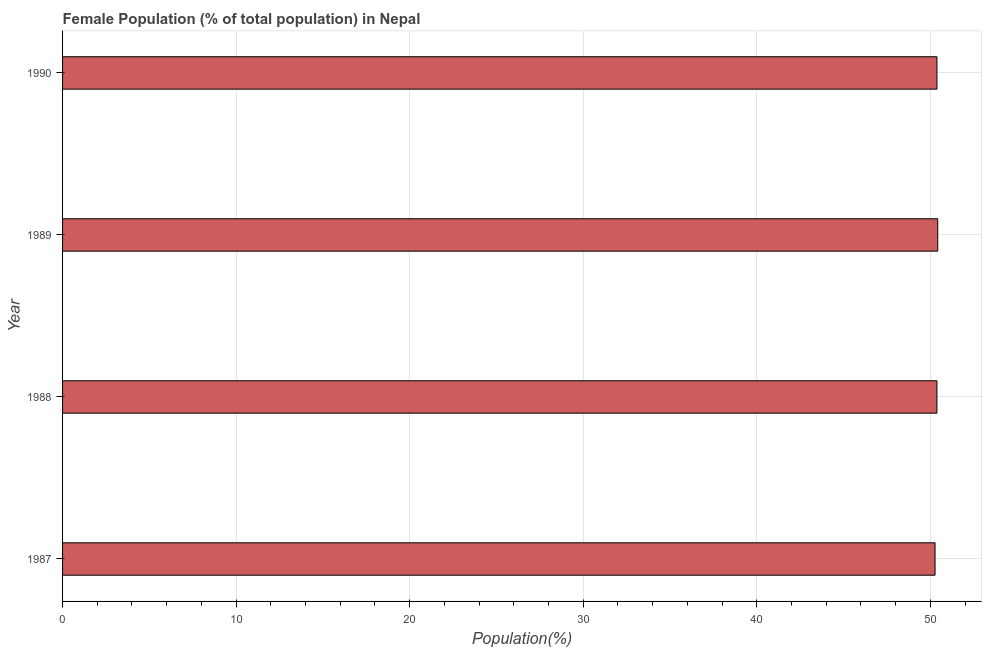Does the graph contain any zero values?
Provide a succinct answer. No. What is the title of the graph?
Provide a short and direct response. Female Population (% of total population) in Nepal. What is the label or title of the X-axis?
Provide a succinct answer. Population(%). What is the label or title of the Y-axis?
Offer a terse response. Year. What is the female population in 1987?
Provide a succinct answer. 50.27. Across all years, what is the maximum female population?
Give a very brief answer. 50.43. Across all years, what is the minimum female population?
Your answer should be very brief. 50.27. What is the sum of the female population?
Keep it short and to the point. 201.47. What is the difference between the female population in 1988 and 1989?
Your answer should be compact. -0.05. What is the average female population per year?
Make the answer very short. 50.37. What is the median female population?
Provide a short and direct response. 50.38. In how many years, is the female population greater than 18 %?
Keep it short and to the point. 4. What is the ratio of the female population in 1987 to that in 1990?
Offer a terse response. 1. Is the female population in 1988 less than that in 1990?
Ensure brevity in your answer.  Yes. What is the difference between the highest and the second highest female population?
Offer a very short reply. 0.04. In how many years, is the female population greater than the average female population taken over all years?
Your answer should be compact. 3. How many bars are there?
Provide a short and direct response. 4. Are all the bars in the graph horizontal?
Make the answer very short. Yes. How many years are there in the graph?
Offer a terse response. 4. What is the difference between two consecutive major ticks on the X-axis?
Your answer should be compact. 10. What is the Population(%) of 1987?
Your answer should be compact. 50.27. What is the Population(%) of 1988?
Keep it short and to the point. 50.38. What is the Population(%) of 1989?
Give a very brief answer. 50.43. What is the Population(%) of 1990?
Offer a very short reply. 50.38. What is the difference between the Population(%) in 1987 and 1988?
Your response must be concise. -0.11. What is the difference between the Population(%) in 1987 and 1989?
Provide a short and direct response. -0.15. What is the difference between the Population(%) in 1987 and 1990?
Keep it short and to the point. -0.11. What is the difference between the Population(%) in 1988 and 1989?
Provide a succinct answer. -0.05. What is the difference between the Population(%) in 1988 and 1990?
Ensure brevity in your answer.  -0. What is the difference between the Population(%) in 1989 and 1990?
Your answer should be very brief. 0.04. What is the ratio of the Population(%) in 1987 to that in 1988?
Ensure brevity in your answer.  1. What is the ratio of the Population(%) in 1987 to that in 1990?
Your answer should be compact. 1. What is the ratio of the Population(%) in 1988 to that in 1989?
Provide a short and direct response. 1. What is the ratio of the Population(%) in 1989 to that in 1990?
Provide a short and direct response. 1. 